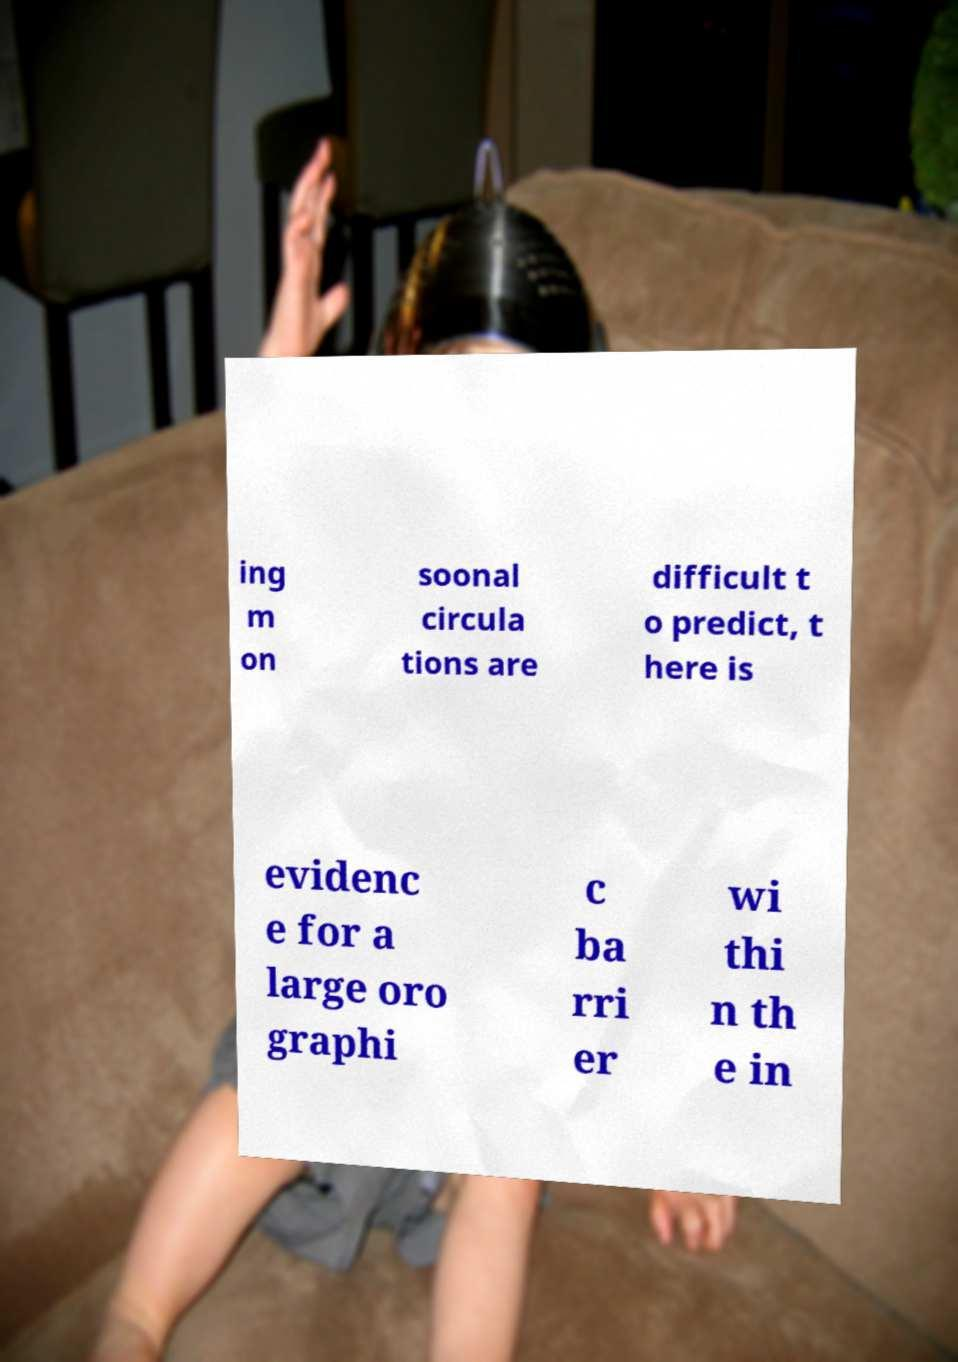Could you assist in decoding the text presented in this image and type it out clearly? ing m on soonal circula tions are difficult t o predict, t here is evidenc e for a large oro graphi c ba rri er wi thi n th e in 